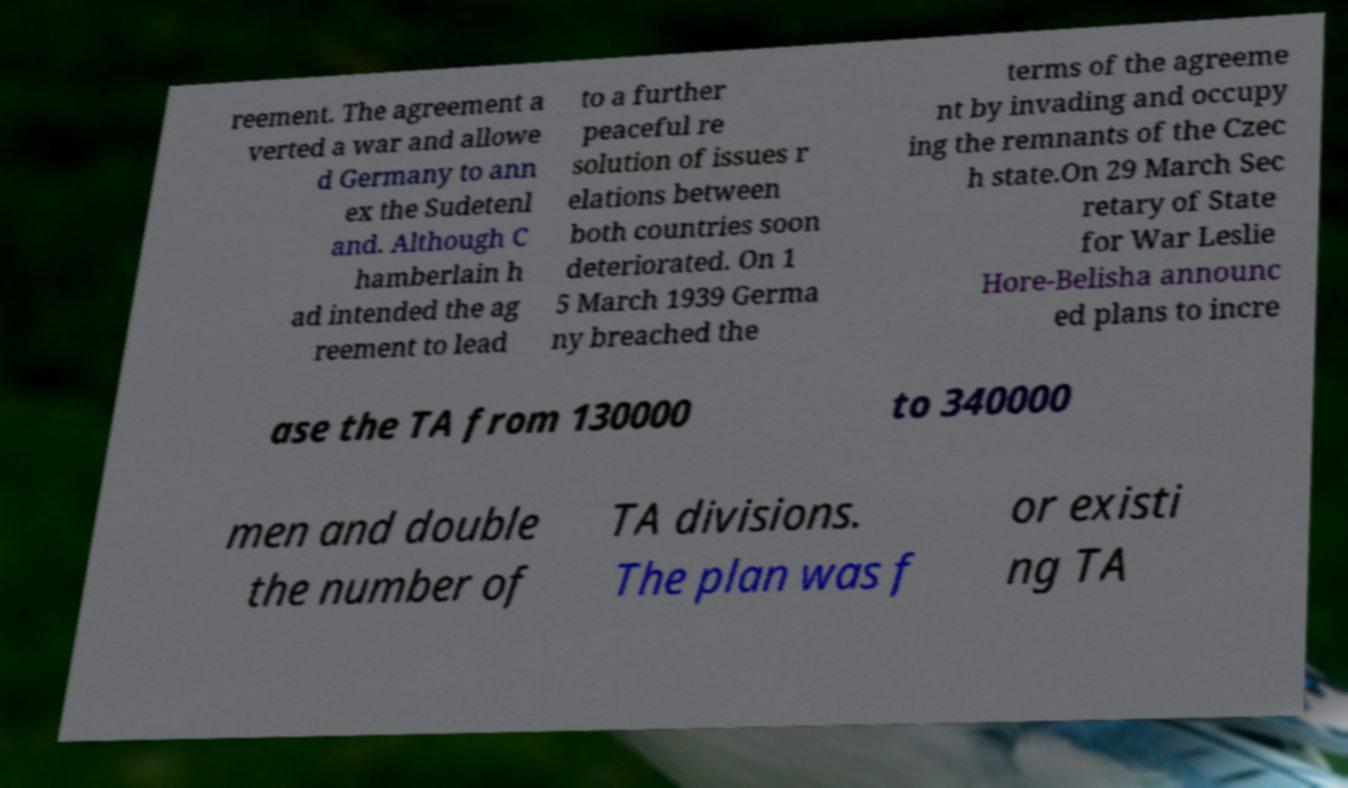What messages or text are displayed in this image? I need them in a readable, typed format. reement. The agreement a verted a war and allowe d Germany to ann ex the Sudetenl and. Although C hamberlain h ad intended the ag reement to lead to a further peaceful re solution of issues r elations between both countries soon deteriorated. On 1 5 March 1939 Germa ny breached the terms of the agreeme nt by invading and occupy ing the remnants of the Czec h state.On 29 March Sec retary of State for War Leslie Hore-Belisha announc ed plans to incre ase the TA from 130000 to 340000 men and double the number of TA divisions. The plan was f or existi ng TA 